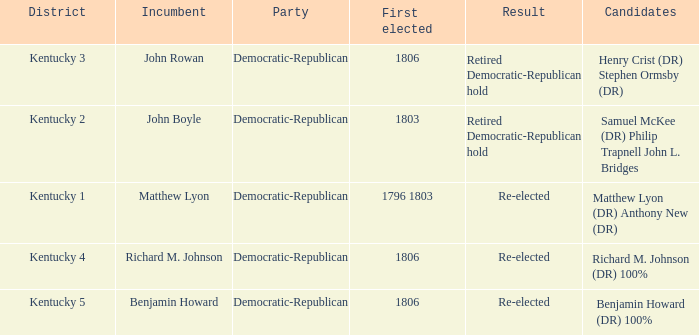Name the incumbent for  matthew lyon (dr) anthony new (dr) Matthew Lyon. 